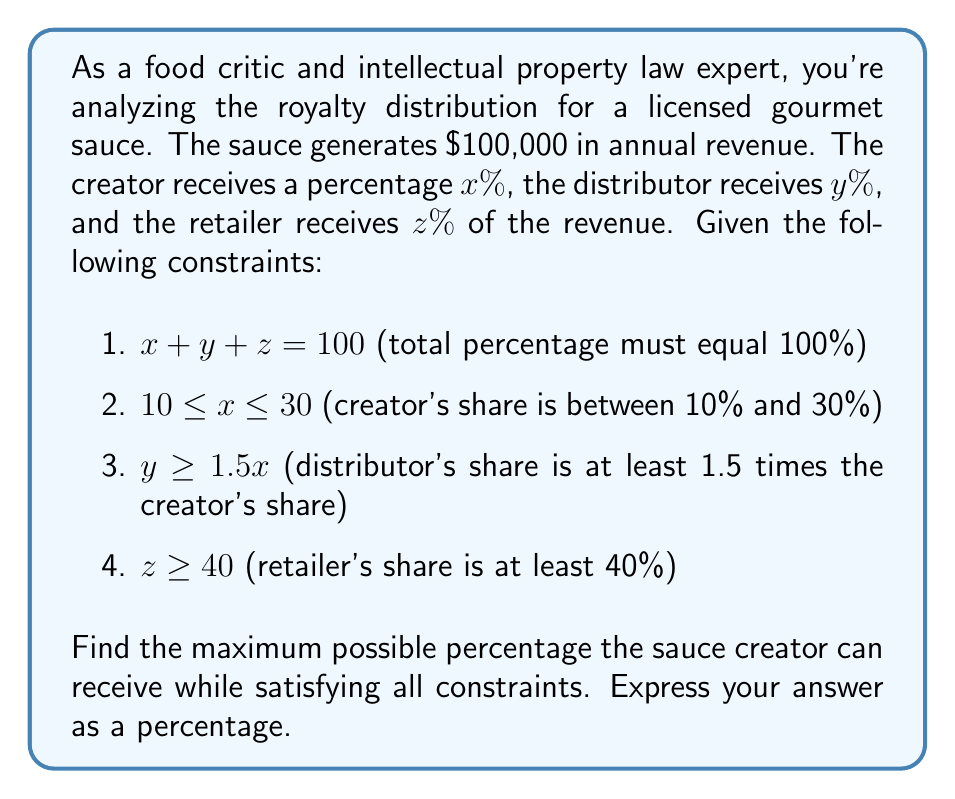Help me with this question. To solve this problem, we'll use a system of inequalities and maximize x (the creator's percentage) while satisfying all constraints.

1. From the given constraints, we have:
   $$x + y + z = 100$$
   $$10 \leq x \leq 30$$
   $$y \geq 1.5x$$
   $$z \geq 40$$

2. Since we want to maximize x, we'll assume z takes its minimum value:
   $$z = 40$$

3. Substituting this into the first equation:
   $$x + y + 40 = 100$$
   $$x + y = 60$$

4. We know that $y \geq 1.5x$, so let's substitute $y = 1.5x$ (since we're maximizing x, y should be at its minimum):
   $$x + 1.5x = 60$$
   $$2.5x = 60$$
   $$x = 24$$

5. Let's verify if this satisfies all constraints:
   - $10 \leq x \leq 30$: 24 is within this range
   - $y = 1.5x = 1.5(24) = 36$
   - $z = 40$
   - $x + y + z = 24 + 36 + 40 = 100$

6. All constraints are satisfied, and x is at its maximum possible value.
Answer: The maximum percentage the sauce creator can receive is 24%. 